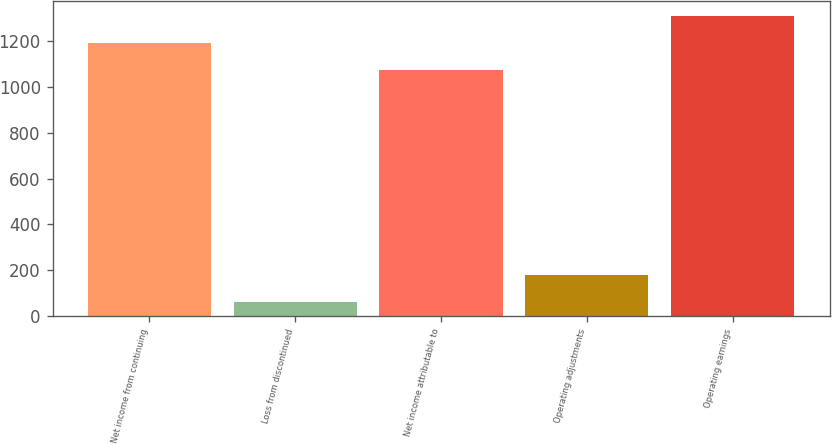Convert chart to OTSL. <chart><loc_0><loc_0><loc_500><loc_500><bar_chart><fcel>Net income from continuing<fcel>Loss from discontinued<fcel>Net income attributable to<fcel>Operating adjustments<fcel>Operating earnings<nl><fcel>1193.2<fcel>60<fcel>1076<fcel>177.2<fcel>1310.4<nl></chart> 